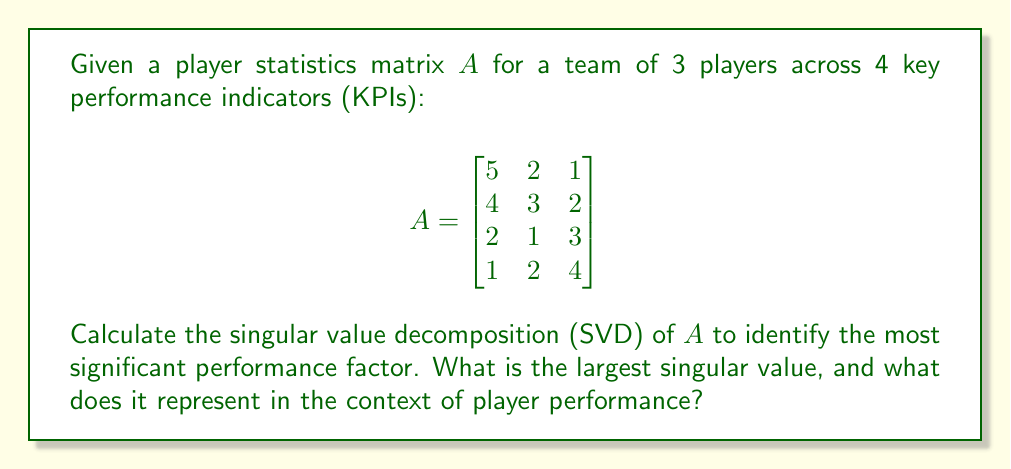Teach me how to tackle this problem. To calculate the singular value decomposition (SVD) of matrix $A$, we follow these steps:

1) First, compute $A^TA$:
   $$A^TA = \begin{bmatrix}
   5 & 4 & 2 & 1 \\
   2 & 3 & 1 & 2 \\
   1 & 2 & 3 & 4
   \end{bmatrix} \begin{bmatrix}
   5 & 2 & 1 \\
   4 & 3 & 2 \\
   2 & 1 & 3 \\
   1 & 2 & 4
   \end{bmatrix} = \begin{bmatrix}
   46 & 29 & 23 \\
   29 & 22 & 21 \\
   23 & 21 & 30
   \end{bmatrix}$$

2) Find the eigenvalues of $A^TA$ by solving $\det(A^TA - \lambda I) = 0$:
   $$\det\begin{bmatrix}
   46-\lambda & 29 & 23 \\
   29 & 22-\lambda & 21 \\
   23 & 21 & 30-\lambda
   \end{bmatrix} = 0$$

   This yields the characteristic equation:
   $$-\lambda^3 + 98\lambda^2 - 1191\lambda + 1980 = 0$$

3) Solve this equation to get the eigenvalues:
   $\lambda_1 \approx 86.60$, $\lambda_2 \approx 10.26$, $\lambda_3 \approx 1.14$

4) The singular values are the square roots of these eigenvalues:
   $\sigma_1 \approx 9.31$, $\sigma_2 \approx 3.20$, $\sigma_3 \approx 1.07$

5) The largest singular value is $\sigma_1 \approx 9.31$.

In the context of player performance, the largest singular value represents the most significant performance factor or pattern in the data. It indicates the direction of maximum variance in the data, which corresponds to the most influential combination of KPIs across all players.

This factor explains the largest portion of the overall performance variation, potentially revealing a key aspect of play style or skill that distinguishes top performers. For a former professional player understanding diverse playing styles, this insight could highlight the most crucial area for team improvement or player recruitment.
Answer: $9.31$ (largest singular value); represents the most significant performance factor 